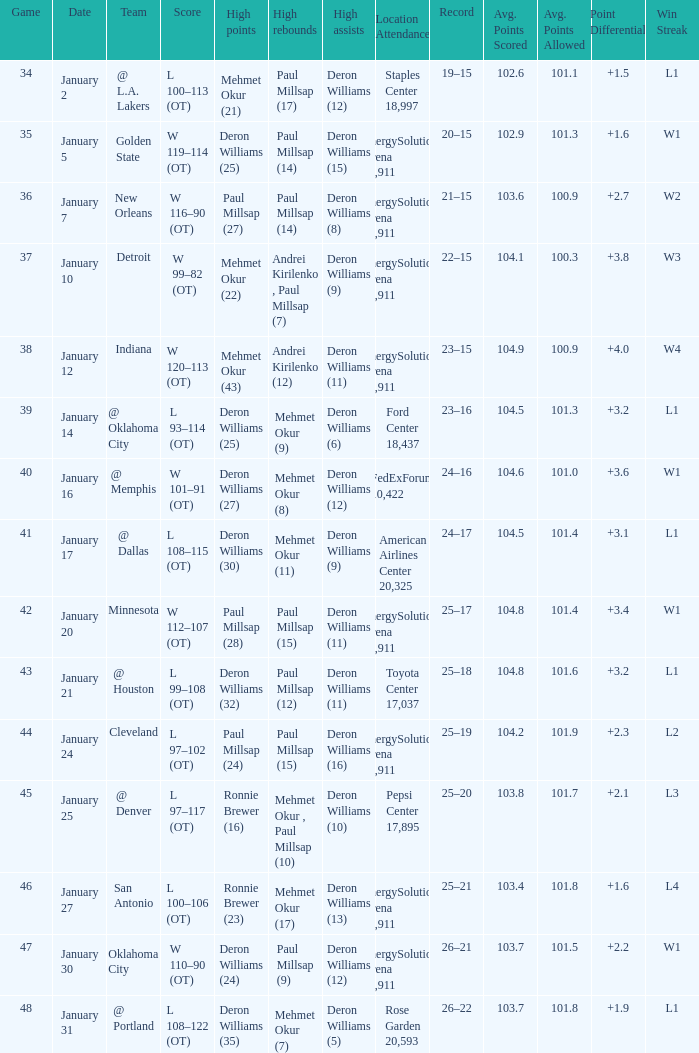Who had the high rebounds on January 24? Paul Millsap (15). 